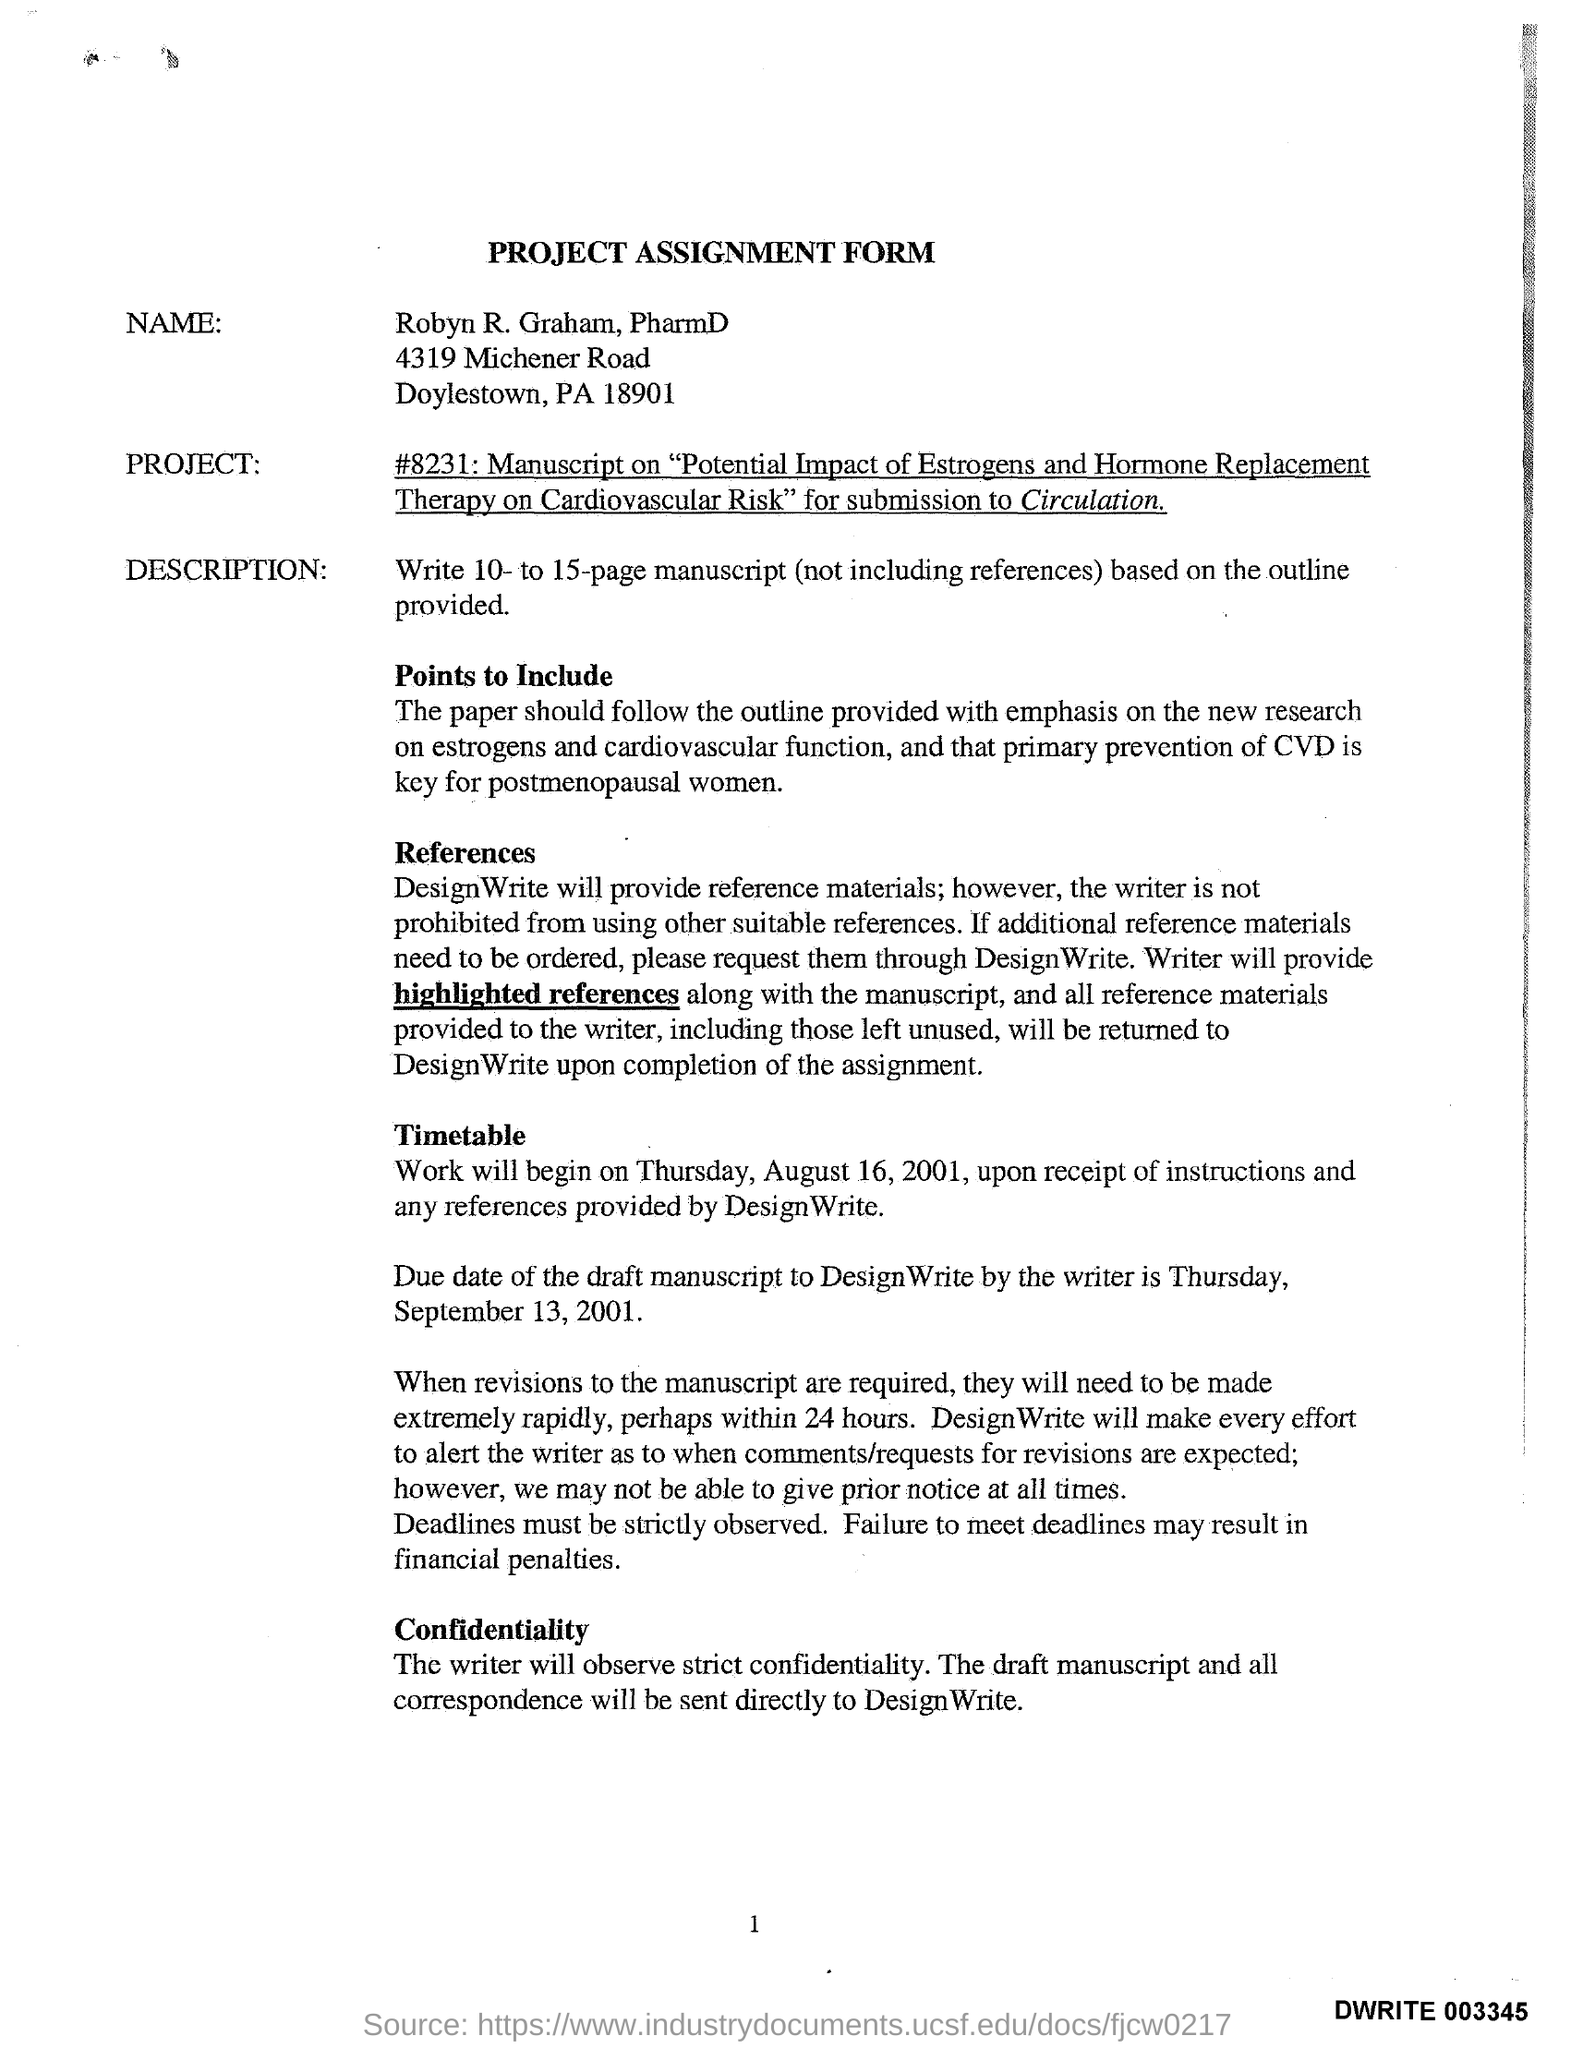Draw attention to some important aspects in this diagram. On August 16, 2001, it was a Thursday. The time duration for revisions of manuscripts is 24 hours. The due date for the draft manuscript is September 13, 2001. 